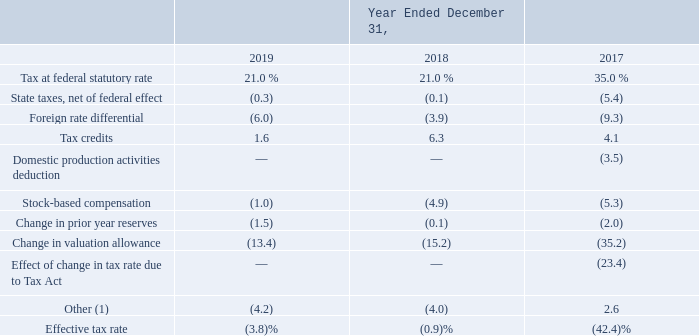The reconciliation of the Company’s effective tax rate to the statutory federal rate is as follows:
(1) For the years ended December 31, 2019 and December 31, 2018, this is inclusive of (3.4%) and (3.8%) impact, respectively, that is primarily related to the change in uncertain tax positions.
For 2019, the Company recorded an expense for income taxes of $11.6 million, resulting in an effective tax rate of (3.8)%. The effective tax rate is different than the U.S. statutory federal tax rate primarily due to stock-based compensation expense following the decision in Altera Corp v. Commissioner by the U.S. Court of Appeals for the Ninth Circuit discussed below, the full valuation allowance on the Company's U.S. deferred tax assets, the mix of income/losses among the Company’s foreign jurisdictions, and pretax losses in jurisdictions for which no tax benefit will be recognized.
What is the income tax expense for 2019? $11.6 million. What are the years that have tax at federal statutory rate of 21.0%? 2018, 2019. What is the effective tax rate in 2017? (42.4)%. What is the average tax at federal statutory rate from 2017-2019?
Answer scale should be: percent. (21.0+21.0+35.0)/3
Answer: 25.67. What is the difference in tax credits between 2018 and 2019?
Answer scale should be: percent. 6.3-1.6
Answer: 4.7. What is the average tax credits from 2017-2019?
Answer scale should be: percent. (1.6+6.3+4.1)/3
Answer: 4. 